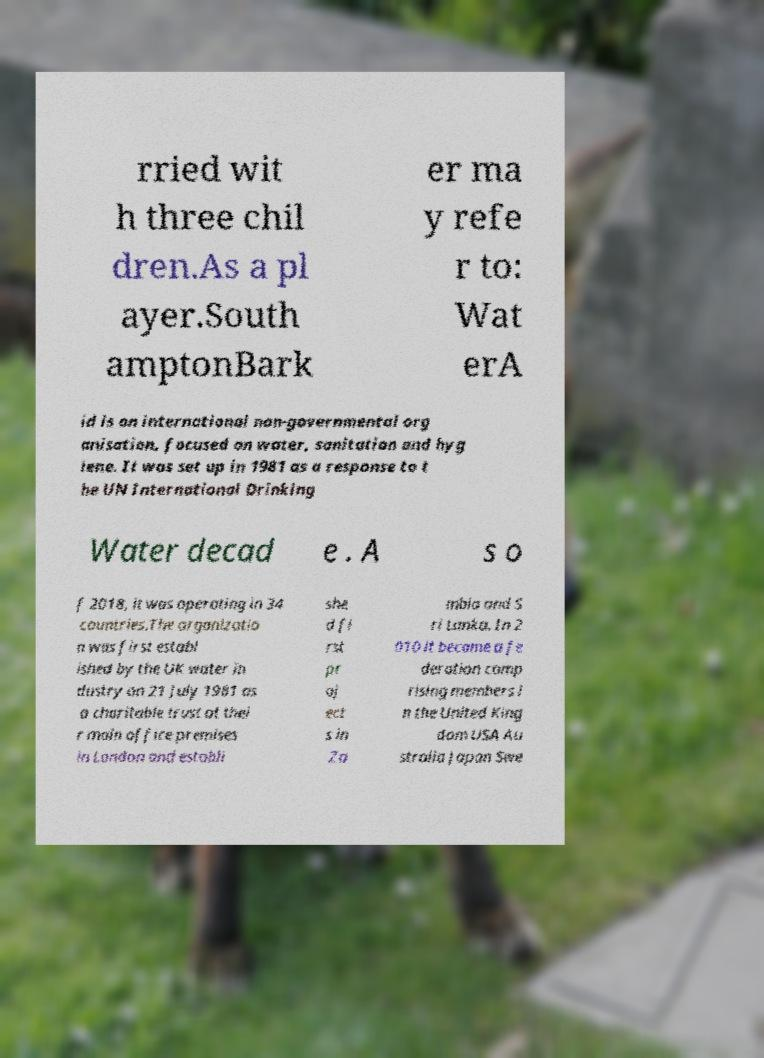Could you extract and type out the text from this image? rried wit h three chil dren.As a pl ayer.South amptonBark er ma y refe r to: Wat erA id is an international non-governmental org anisation, focused on water, sanitation and hyg iene. It was set up in 1981 as a response to t he UN International Drinking Water decad e . A s o f 2018, it was operating in 34 countries.The organizatio n was first establ ished by the UK water in dustry on 21 July 1981 as a charitable trust at thei r main office premises in London and establi she d fi rst pr oj ect s in Za mbia and S ri Lanka. In 2 010 it became a fe deration comp rising members i n the United King dom USA Au stralia Japan Swe 